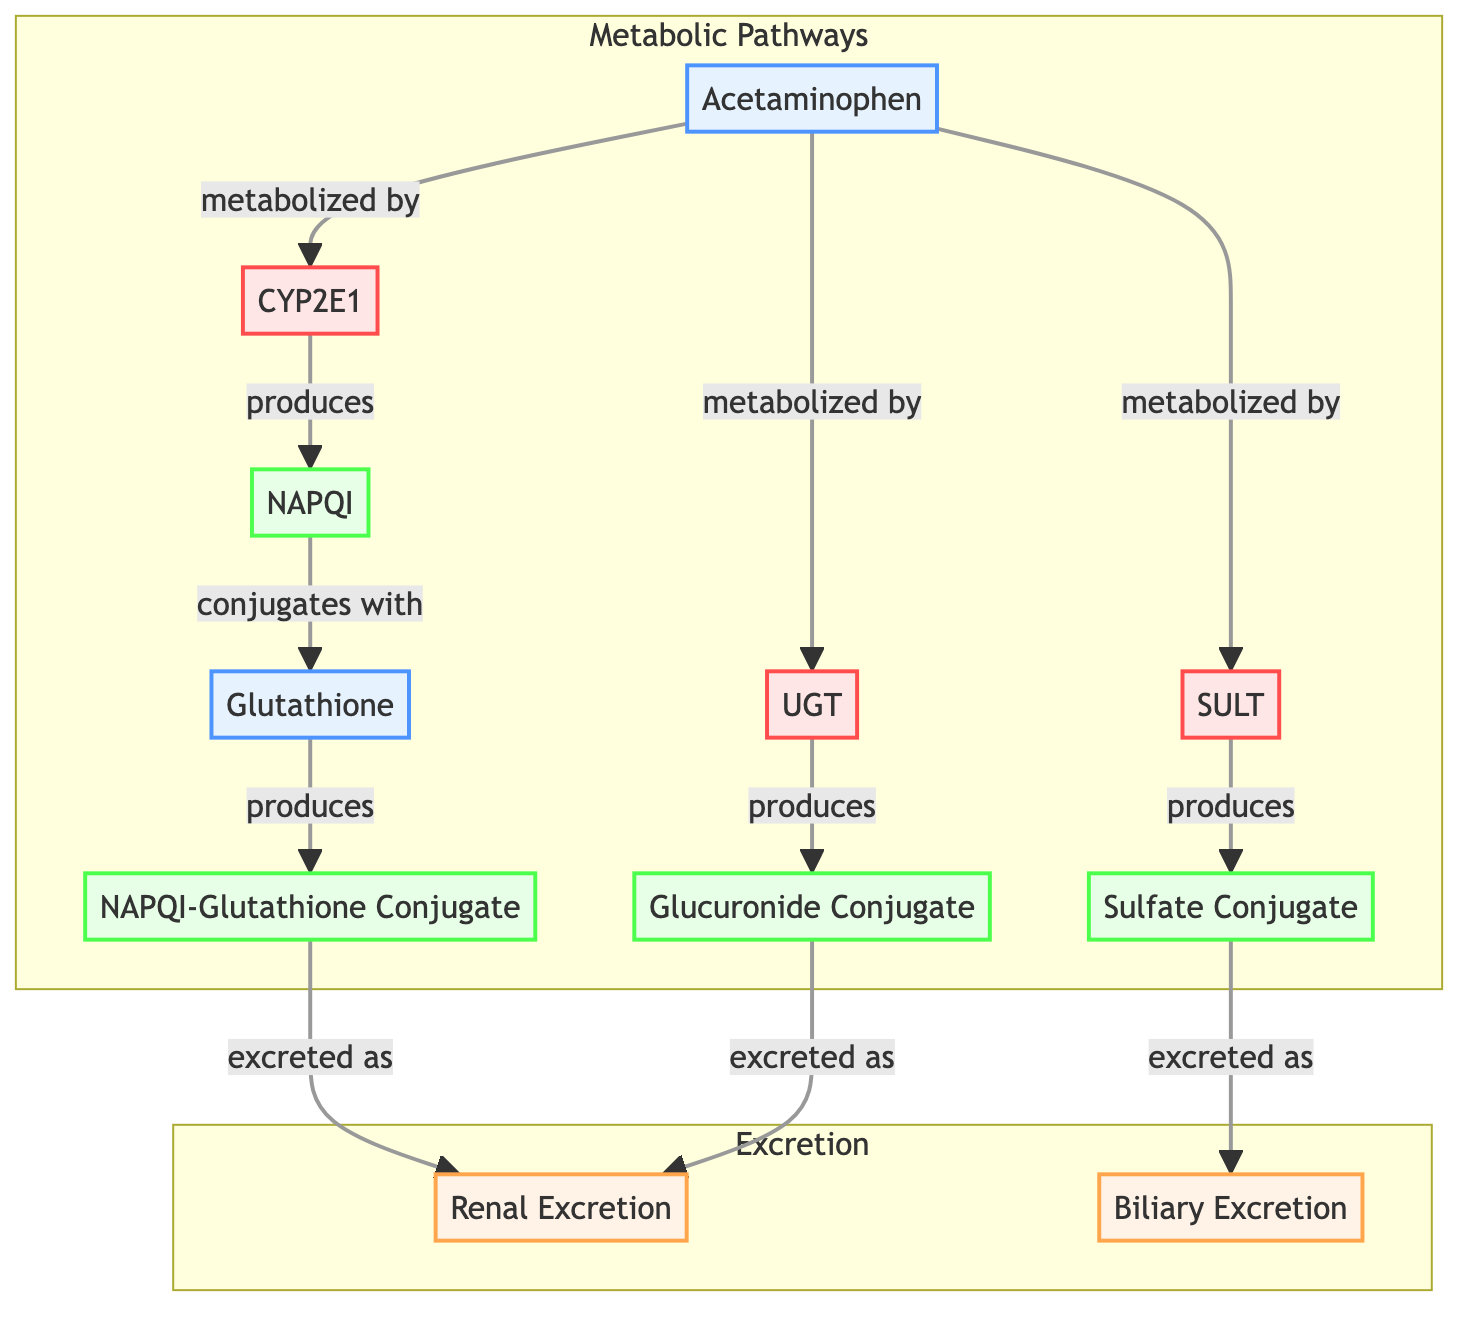What is the substrate at the beginning of the pathway? The diagram indicates that the pathway begins with Acetaminophen, which is labeled as the starting substrate.
Answer: Acetaminophen How many enzymes are involved in the metabolic pathway? Upon examining the diagram, there are three enzymes listed: CYP2E1, UGT, and SULT, making a total of three enzymes involved in the metabolic transformations.
Answer: 3 What is the first intermediate product formed in the pathway? Tracing the flow from the substrate, the first reaction involving the enzyme CYP2E1 results in the production of NAPQI, which is the initial intermediate product formed.
Answer: NAPQI Which intermediate conjugates with Glutathione? Following the flow from NAPQI, it is directed to Glutathione, where the conjugation occurs to form the NAPQI-Glutathione Conjugate.
Answer: NAPQI How are the products Glucuronide Conjugate and Sulfate Conjugate formed? The Glucuronide Conjugate is produced from the enzymatic metabolism of Acetaminophen by UGT, while the Sulfate Conjugate is produced by SULT. Both are derived from Acetaminophen through separate enzymatic pathways.
Answer: Glucuronide Conjugate and Sulfate Conjugate What type of excretion occurs for the NAPQI-Glutathione Conjugate? The diagram indicates that the NAPQI-Glutathione Conjugate is excreted primarily through renal excretion.
Answer: Renal Excretion What happens to the Glucuronide Conjugate after it is produced? After the Glucuronide Conjugate is generated, the diagram shows that it is also excreted via renal excretion, indicating its route post-formation.
Answer: Renal Excretion How many total pathways lead to excretion? There are two separate pathways leading toward excretion: one for the NAPQI-Glutathione Conjugate (renal excretion) and another pathway for the Glucuronide Conjugate (also renal excretion), and the sulfate conjugate (biliary excretion), totaling three pathways.
Answer: 3 